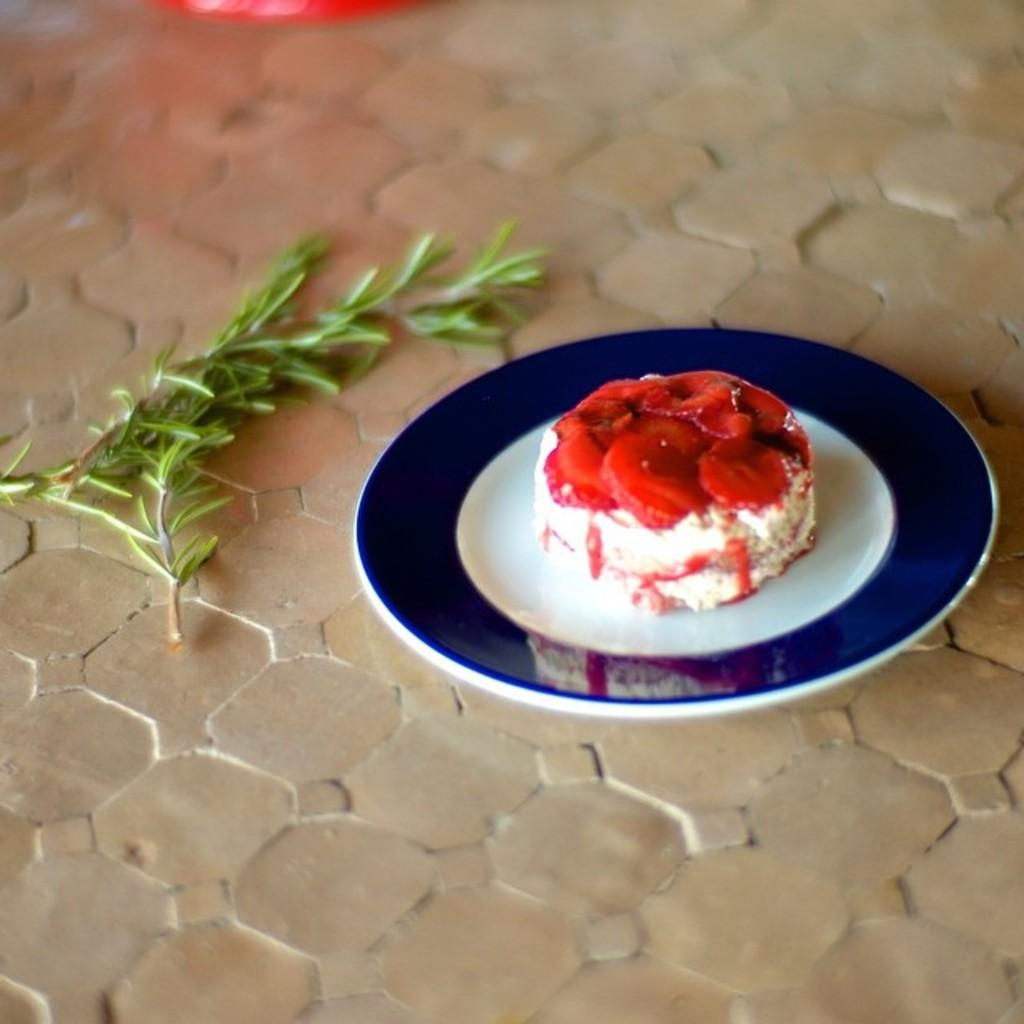What is on the plate that is visible in the image? There is food on a plate in the image. Where is the plate located in the image? The plate is in the center of the image. What can be seen on the left side of the plate? There are leaves on the left side of the plate. What is on top of the plate in the image? There is an object on top of the plate. What is the color of the object on the plate? The object is red in color. How many women are visible in the image? There are no women visible in the image; it only features a plate with food, leaves, and a red object. 